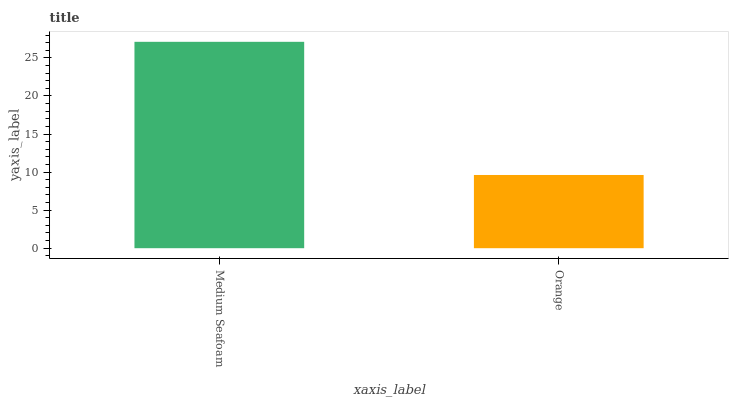Is Orange the minimum?
Answer yes or no. Yes. Is Medium Seafoam the maximum?
Answer yes or no. Yes. Is Orange the maximum?
Answer yes or no. No. Is Medium Seafoam greater than Orange?
Answer yes or no. Yes. Is Orange less than Medium Seafoam?
Answer yes or no. Yes. Is Orange greater than Medium Seafoam?
Answer yes or no. No. Is Medium Seafoam less than Orange?
Answer yes or no. No. Is Medium Seafoam the high median?
Answer yes or no. Yes. Is Orange the low median?
Answer yes or no. Yes. Is Orange the high median?
Answer yes or no. No. Is Medium Seafoam the low median?
Answer yes or no. No. 